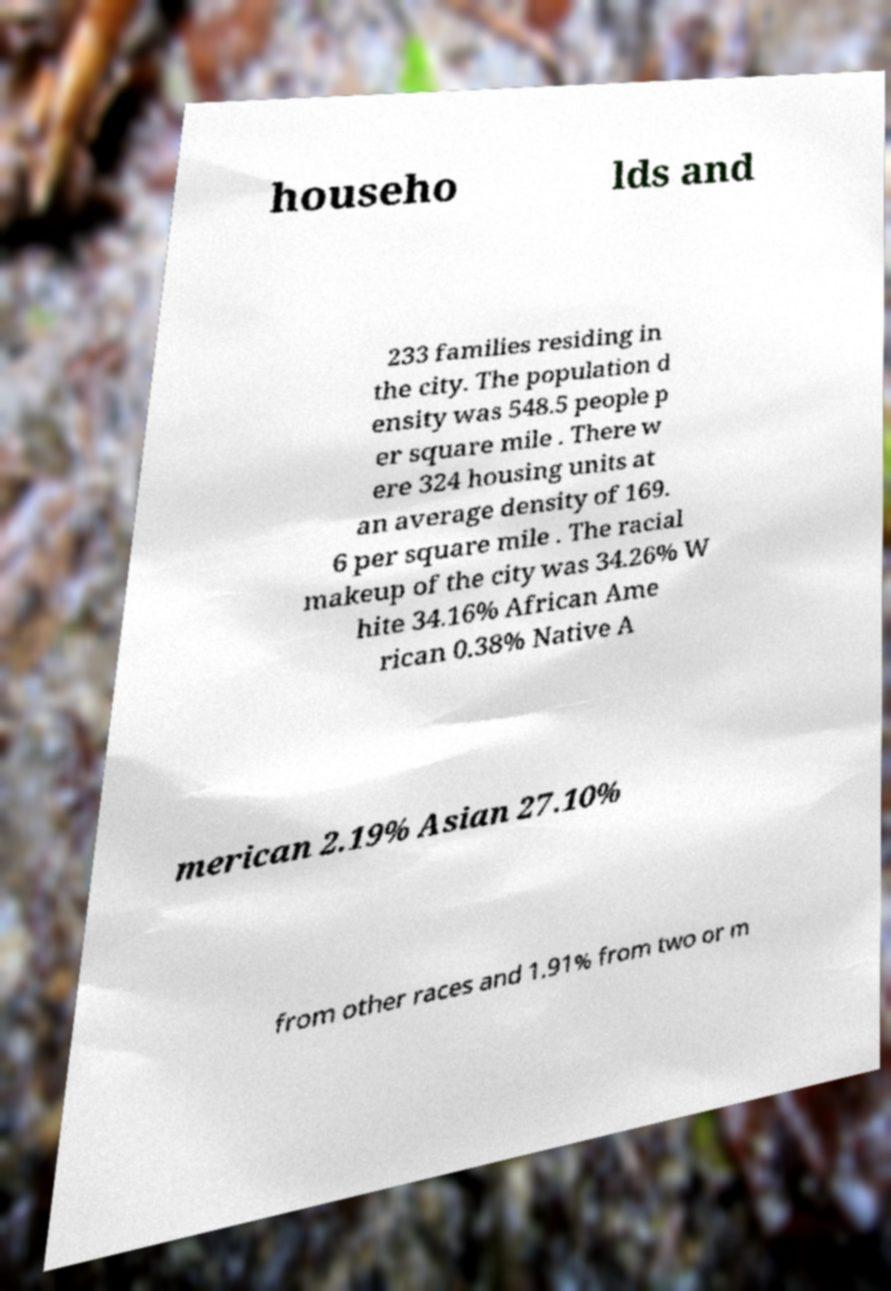What messages or text are displayed in this image? I need them in a readable, typed format. househo lds and 233 families residing in the city. The population d ensity was 548.5 people p er square mile . There w ere 324 housing units at an average density of 169. 6 per square mile . The racial makeup of the city was 34.26% W hite 34.16% African Ame rican 0.38% Native A merican 2.19% Asian 27.10% from other races and 1.91% from two or m 